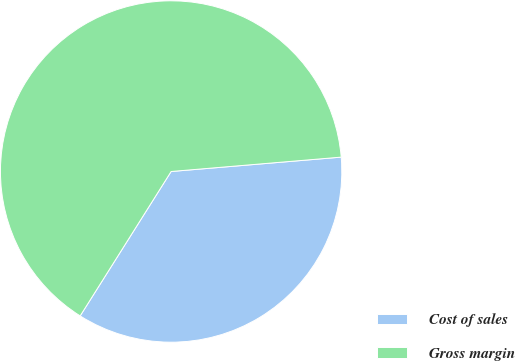Convert chart to OTSL. <chart><loc_0><loc_0><loc_500><loc_500><pie_chart><fcel>Cost of sales<fcel>Gross margin<nl><fcel>35.29%<fcel>64.71%<nl></chart> 